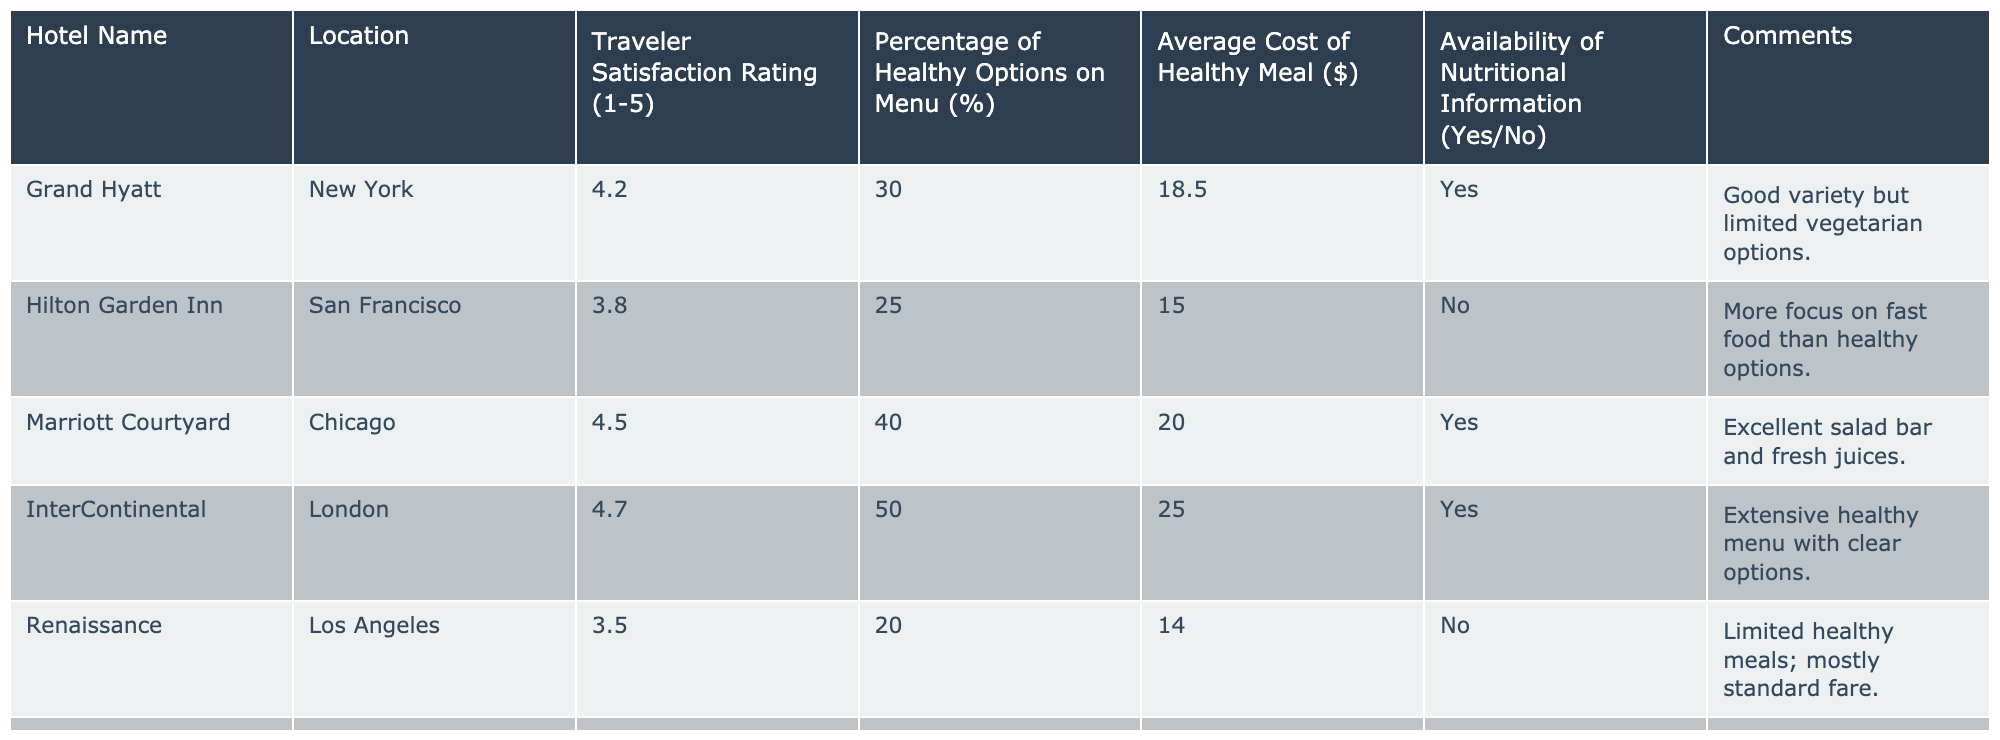What is the highest traveler satisfaction rating among the hotels listed? The table lists the traveler satisfaction ratings for each hotel. By reviewing the ratings, I find that the highest rating is 4.8 for the Four Seasons in Tokyo.
Answer: 4.8 Which hotel has the lowest percentage of healthy options on the menu? The table shows the percentage of healthy options for each hotel. The lowest percentage is 20%, which is offered by the Renaissance in Los Angeles.
Answer: 20% How many hotels provide nutritional information for their healthy options? Looking at the table, I count the "Yes" responses in the Availability of Nutritional Information column. There are four hotels with "Yes" responses (Grand Hyatt, Marriott Courtyard, InterContinental, Four Seasons).
Answer: 4 What is the average cost of a healthy meal across all hotels? To calculate the average cost, I need to add the average costs of healthy meals from all hotels and then divide that sum by the number of hotels. The costs are: 18.50, 15.00, 20.00, 25.00, 14.00, 30.00, 21.00, 17.50, summing these values gives 141.00 and dividing by 8 gives 17.625.
Answer: 17.63 Is it true that all hotels with a satisfaction rating above 4.5 provide nutritional information? I check the table for hotels with ratings above 4.5 (InterContinental and Four Seasons). Both of these hotels provide nutritional information (Yes). Thus, this statement is true.
Answer: Yes Which hotel has the highest percentage of healthy options and what is its average cost of a healthy meal? The table lists the percentage of healthy options. The Four Seasons in Tokyo has the highest percentage at 55%. Its corresponding average cost of a healthy meal is $30.00.
Answer: Four Seasons, $30.00 Are there any hotels that have a satisfaction rating below 4.0 and do not provide nutritional information? I scan through the ratings and find the hotels with ratings below 4.0 (Renaissance at 3.5 and W Hotels at 3.6) and check their nutritional information status. Both do not provide nutritional information (No). Hence, there are hotels that meet this criteria.
Answer: Yes What is the total traveler satisfaction rating for hotels located in the same city as the Grand Hyatt? The Grand Hyatt is in New York; the only other hotel in New York that is listed is the Hilton Garden Inn. Adding their ratings gives 4.2 (Grand Hyatt) + 3.8 (Hilton Garden Inn) = 8.0.
Answer: 8.0 Do any hotels with less than 30% healthy options still have a satisfaction rating of 4 or above? I look at hotels with less than 30% healthy options, which are Hilton Garden Inn (3.8), Renaissance (3.5), and W Hotels (3.6). None of these have a rating of 4 or above.
Answer: No 